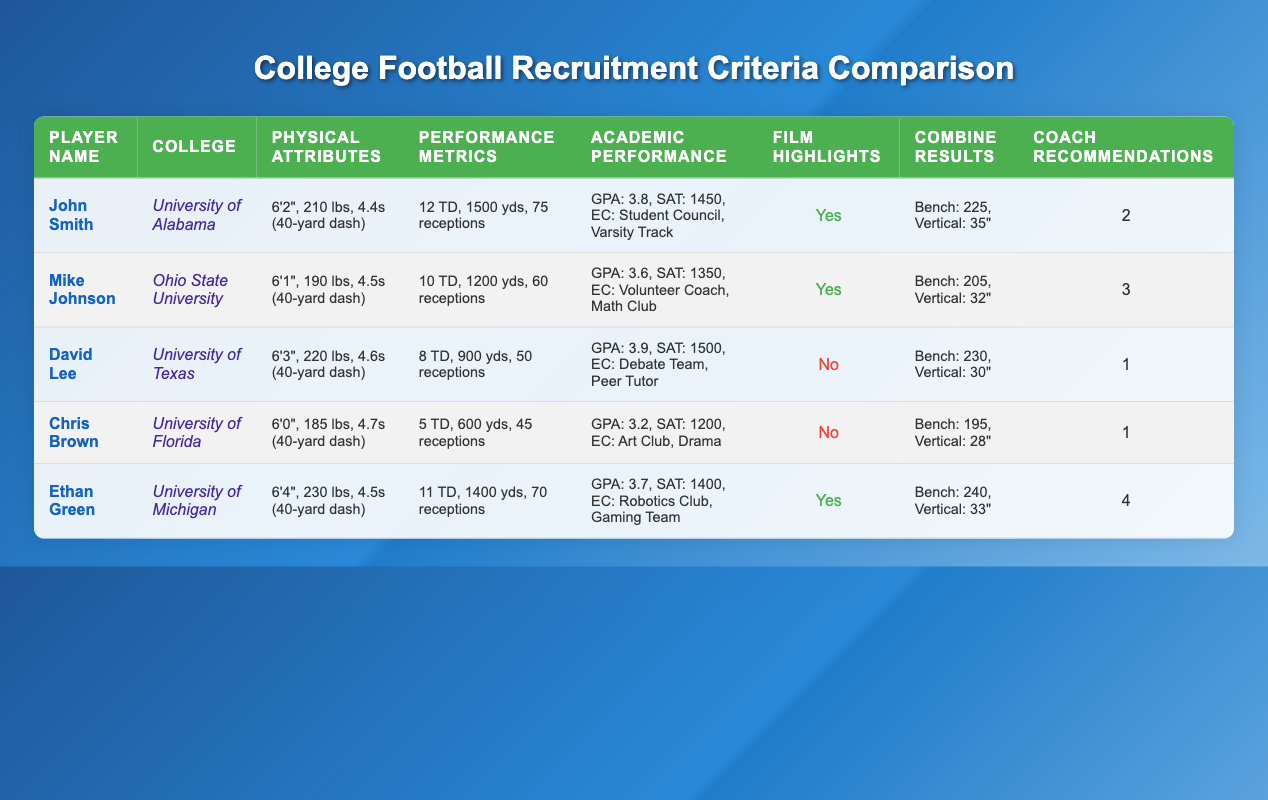What is the highest number of touchdowns scored by a player? The highest number of touchdowns scored is found by inspecting the "Touchdowns" column. John Smith scored 12 touchdowns, which is higher than the other players listed (Mike Johnson with 10, David Lee with 8, Chris Brown with 5, and Ethan Green with 11).
Answer: 12 Which player has the lowest GPA? To find the lowest GPA, I will compare the GPAs from each player. The GPAs are as follows: John Smith (3.8), Mike Johnson (3.6), David Lee (3.9), Chris Brown (3.2), and Ethan Green (3.7). Chris Brown has the lowest GPA of 3.2.
Answer: 3.2 How many total touchdowns do the players have combined? I will sum the total touchdowns scored: John Smith (12) + Mike Johnson (10) + David Lee (8) + Chris Brown (5) + Ethan Green (11) = 46. The total number of touchdowns scored by the players is 46.
Answer: 46 Is there at least one player who has film highlights? I will verify whether any player's "Film Highlights" value is true. Looking at the table, John Smith, Mike Johnson, and Ethan Green have film highlights, meaning there are players with film highlights.
Answer: Yes Who has the highest number of coach recommendations? I will examine the "Coach Recommendations" column for each player. They have the following recommendations: John Smith (2), Mike Johnson (3), David Lee (1), Chris Brown (1), and Ethan Green (4). Ethan Green has the highest number with 4 recommendations.
Answer: Ethan Green What is the weight difference between the heaviest and lightest player? To find the weight difference, I compare "Weight" values. The heaviest player is David Lee at 220 lbs, and the lightest is Chris Brown at 185 lbs. The weight difference is calculated as 220 lbs - 185 lbs = 35 lbs.
Answer: 35 lbs What percentage of players have a GPA of 3.5 or higher? I will count how many players have GPA values of 3.5 or higher. Those are John Smith (3.8), Mike Johnson (3.6), David Lee (3.9), and Ethan Green (3.7). That's 4 players out of 5 total players, which gives a percentage of (4/5) * 100 = 80%.
Answer: 80% What is the average vertical jump of the players? The vertical jumps are: John Smith (35"), Mike Johnson (32"), David Lee (30"), Chris Brown (28"), and Ethan Green (33"). I will sum these values: 35 + 32 + 30 + 28 + 33 = 158. There are five players, so the average vertical jump is 158 / 5 = 31.6 inches.
Answer: 31.6 inches 